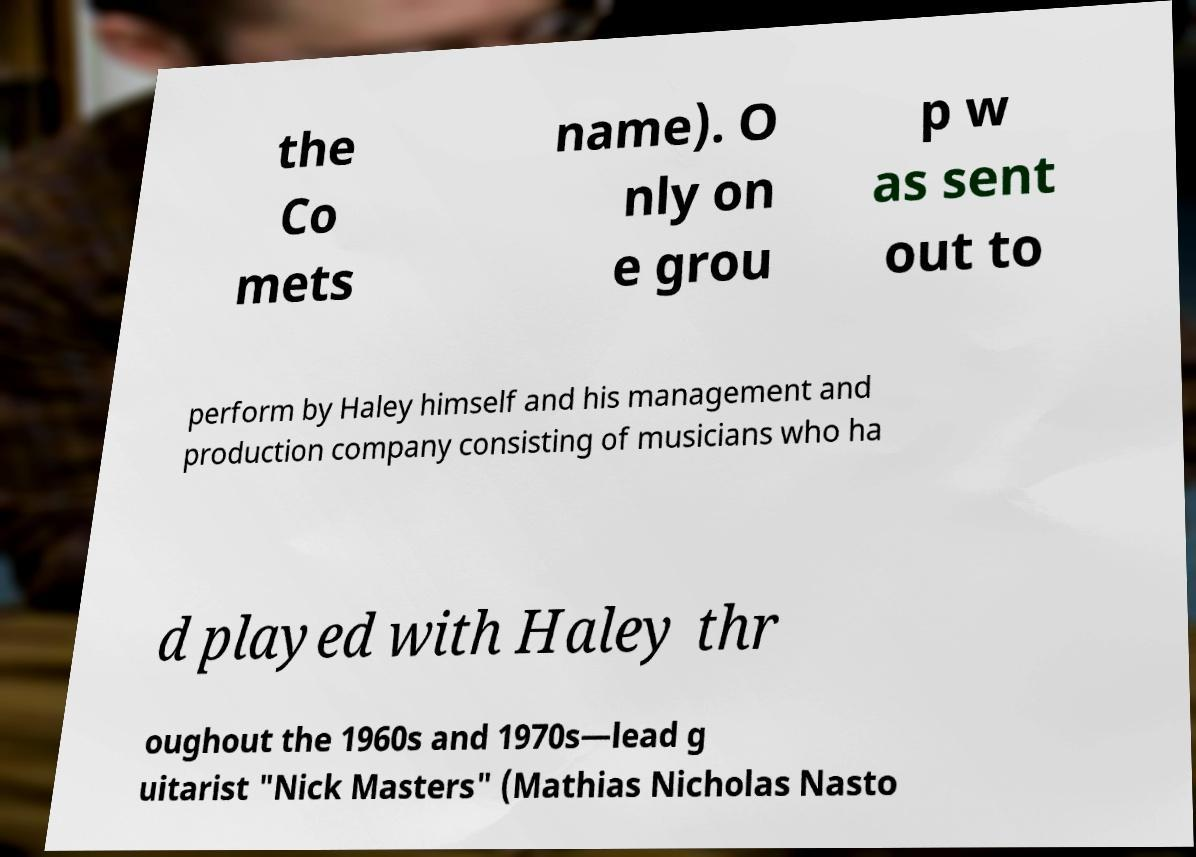Please read and relay the text visible in this image. What does it say? the Co mets name). O nly on e grou p w as sent out to perform by Haley himself and his management and production company consisting of musicians who ha d played with Haley thr oughout the 1960s and 1970s—lead g uitarist "Nick Masters" (Mathias Nicholas Nasto 